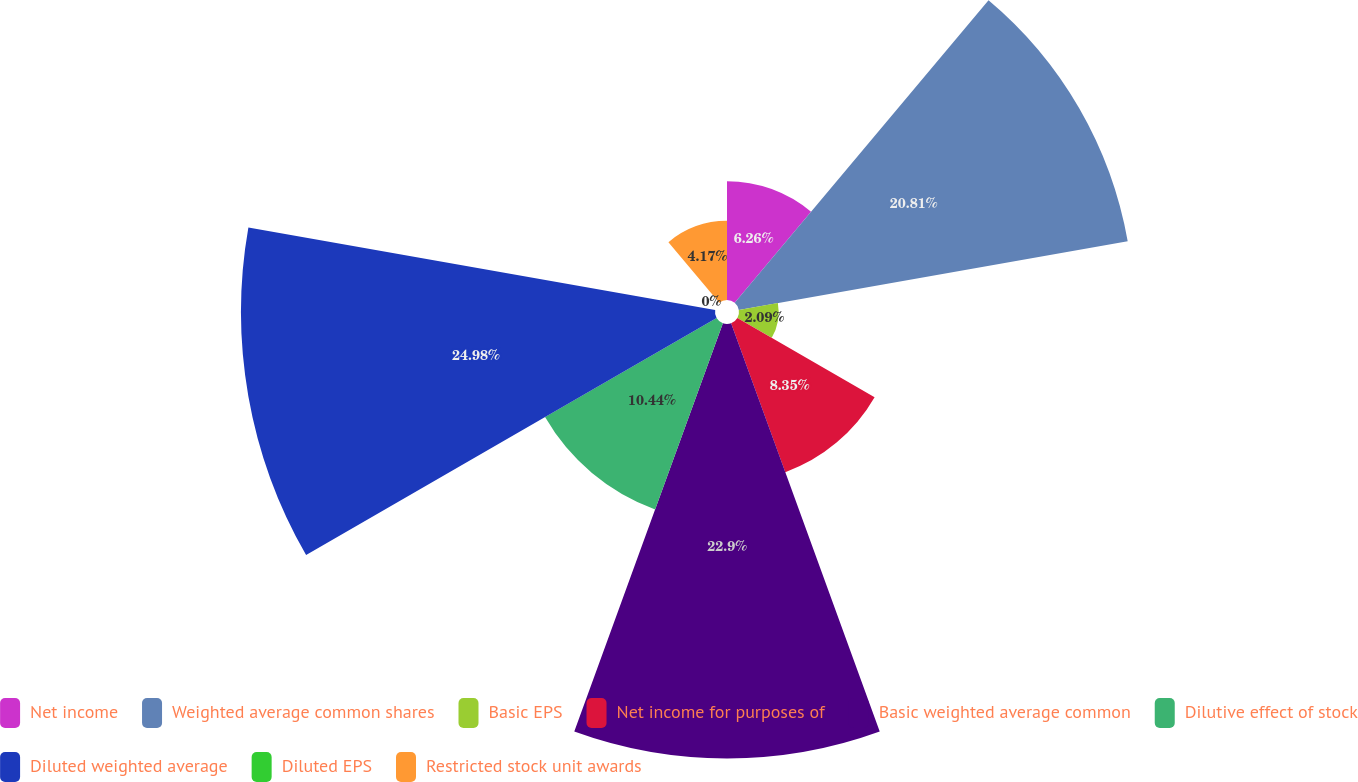Convert chart to OTSL. <chart><loc_0><loc_0><loc_500><loc_500><pie_chart><fcel>Net income<fcel>Weighted average common shares<fcel>Basic EPS<fcel>Net income for purposes of<fcel>Basic weighted average common<fcel>Dilutive effect of stock<fcel>Diluted weighted average<fcel>Diluted EPS<fcel>Restricted stock unit awards<nl><fcel>6.26%<fcel>20.81%<fcel>2.09%<fcel>8.35%<fcel>22.9%<fcel>10.44%<fcel>24.98%<fcel>0.0%<fcel>4.17%<nl></chart> 